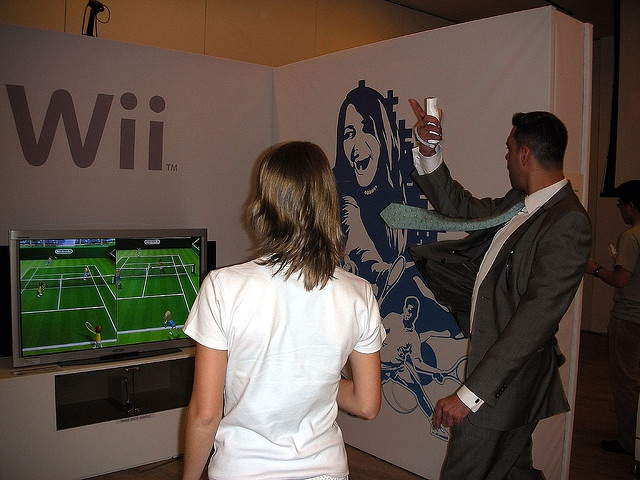Describe the objects in this image and their specific colors. I can see people in black, white, gray, and maroon tones, people in black, maroon, gray, and darkgray tones, tv in black, darkgreen, and gray tones, people in black, maroon, and gray tones, and tie in black and gray tones in this image. 